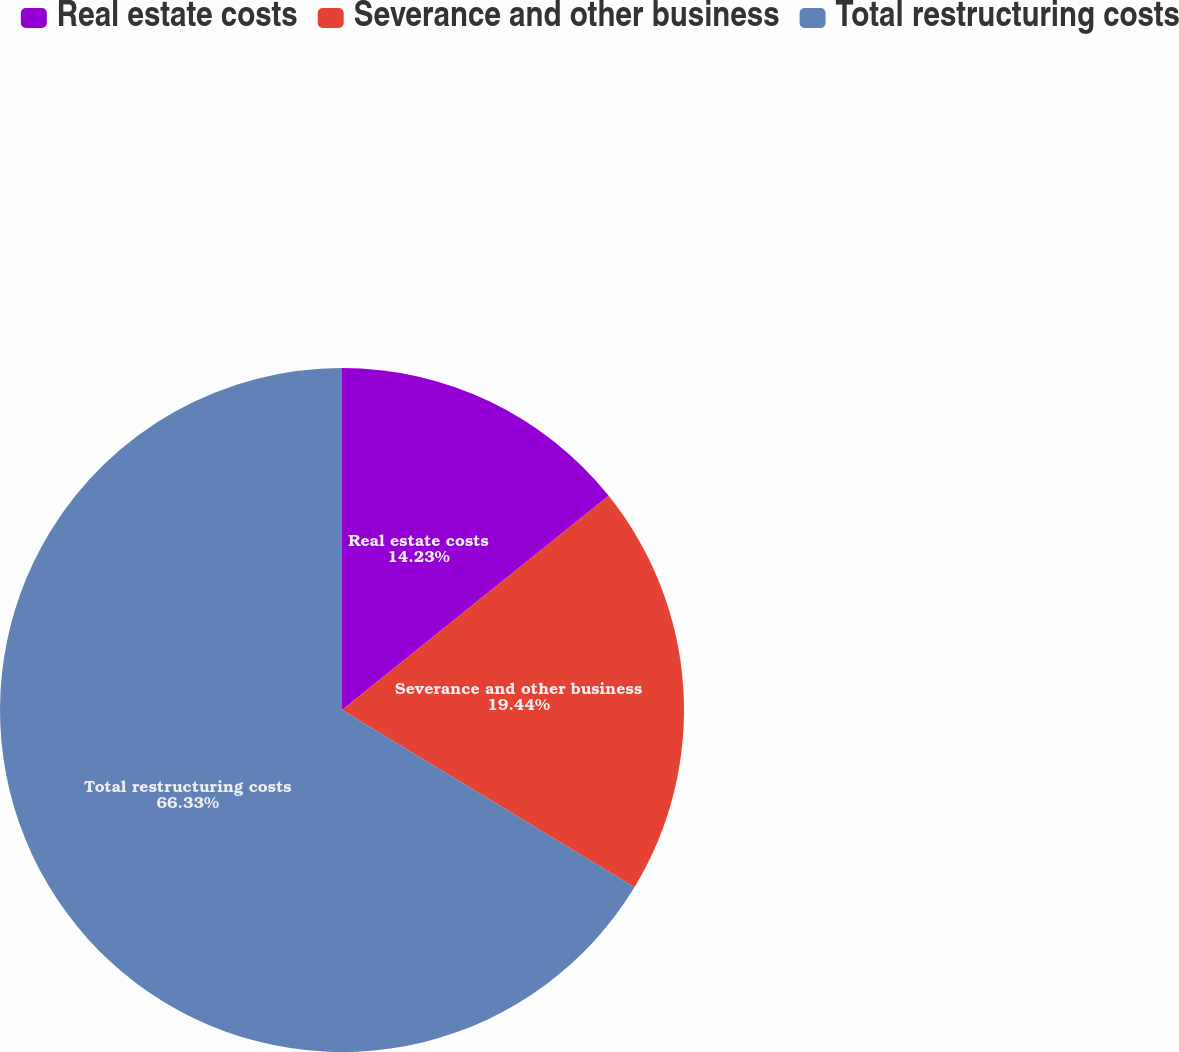Convert chart. <chart><loc_0><loc_0><loc_500><loc_500><pie_chart><fcel>Real estate costs<fcel>Severance and other business<fcel>Total restructuring costs<nl><fcel>14.23%<fcel>19.44%<fcel>66.32%<nl></chart> 